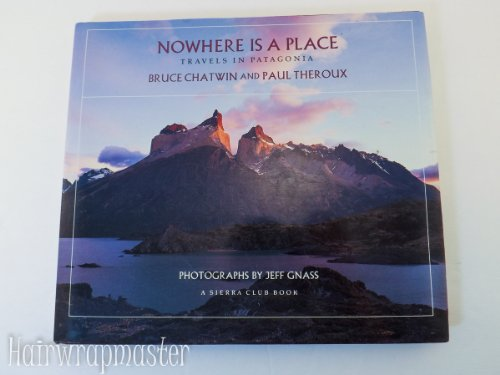Can you tell us more about the significance of Patagonia in this book? Patagonia, a remote region at the southern tip of South America, is depicted as a rugged, untouched wilderness that poses both physical and philosophical challenges to travelers. The book explores its vast landscapes, unique biodiversity, and the intriguing stories of people who dwell there, making it a central character in the travel stories of Chatwin and Theroux. 